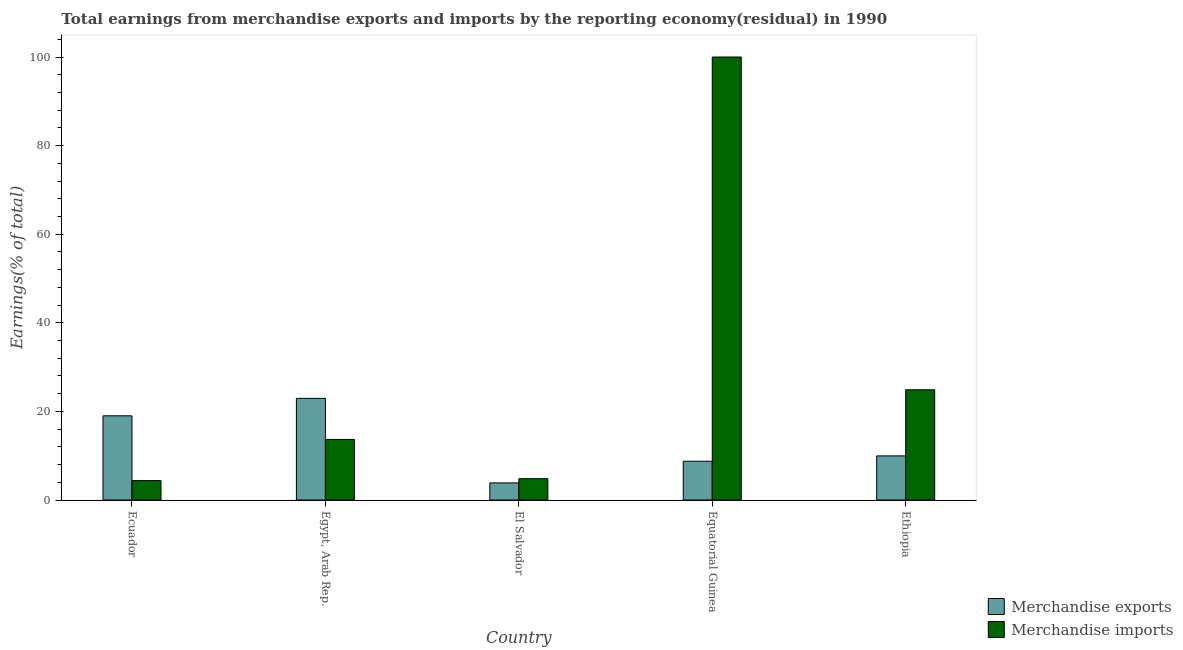How many different coloured bars are there?
Offer a terse response. 2. How many groups of bars are there?
Provide a short and direct response. 5. How many bars are there on the 5th tick from the left?
Keep it short and to the point. 2. What is the label of the 1st group of bars from the left?
Keep it short and to the point. Ecuador. What is the earnings from merchandise exports in El Salvador?
Keep it short and to the point. 3.86. Across all countries, what is the maximum earnings from merchandise exports?
Keep it short and to the point. 22.94. Across all countries, what is the minimum earnings from merchandise exports?
Make the answer very short. 3.86. In which country was the earnings from merchandise exports maximum?
Provide a short and direct response. Egypt, Arab Rep. In which country was the earnings from merchandise exports minimum?
Offer a terse response. El Salvador. What is the total earnings from merchandise exports in the graph?
Your response must be concise. 64.51. What is the difference between the earnings from merchandise exports in El Salvador and that in Equatorial Guinea?
Your answer should be very brief. -4.89. What is the difference between the earnings from merchandise imports in Ecuador and the earnings from merchandise exports in Equatorial Guinea?
Provide a short and direct response. -4.38. What is the average earnings from merchandise imports per country?
Your response must be concise. 29.55. What is the difference between the earnings from merchandise imports and earnings from merchandise exports in Ecuador?
Provide a succinct answer. -14.63. In how many countries, is the earnings from merchandise exports greater than 28 %?
Offer a terse response. 0. What is the ratio of the earnings from merchandise exports in Egypt, Arab Rep. to that in Equatorial Guinea?
Provide a succinct answer. 2.62. Is the difference between the earnings from merchandise exports in Ecuador and Equatorial Guinea greater than the difference between the earnings from merchandise imports in Ecuador and Equatorial Guinea?
Your response must be concise. Yes. What is the difference between the highest and the second highest earnings from merchandise exports?
Give a very brief answer. 3.94. What is the difference between the highest and the lowest earnings from merchandise exports?
Make the answer very short. 19.08. What does the 1st bar from the left in Egypt, Arab Rep. represents?
Give a very brief answer. Merchandise exports. How many bars are there?
Provide a succinct answer. 10. What is the difference between two consecutive major ticks on the Y-axis?
Provide a short and direct response. 20. Are the values on the major ticks of Y-axis written in scientific E-notation?
Make the answer very short. No. Does the graph contain any zero values?
Your response must be concise. No. Does the graph contain grids?
Make the answer very short. No. How many legend labels are there?
Make the answer very short. 2. How are the legend labels stacked?
Ensure brevity in your answer.  Vertical. What is the title of the graph?
Your response must be concise. Total earnings from merchandise exports and imports by the reporting economy(residual) in 1990. Does "IMF nonconcessional" appear as one of the legend labels in the graph?
Offer a terse response. No. What is the label or title of the Y-axis?
Give a very brief answer. Earnings(% of total). What is the Earnings(% of total) of Merchandise exports in Ecuador?
Your response must be concise. 19. What is the Earnings(% of total) in Merchandise imports in Ecuador?
Keep it short and to the point. 4.38. What is the Earnings(% of total) in Merchandise exports in Egypt, Arab Rep.?
Provide a short and direct response. 22.94. What is the Earnings(% of total) in Merchandise imports in Egypt, Arab Rep.?
Provide a succinct answer. 13.68. What is the Earnings(% of total) of Merchandise exports in El Salvador?
Provide a short and direct response. 3.86. What is the Earnings(% of total) in Merchandise imports in El Salvador?
Your answer should be compact. 4.81. What is the Earnings(% of total) of Merchandise exports in Equatorial Guinea?
Your answer should be very brief. 8.75. What is the Earnings(% of total) in Merchandise exports in Ethiopia?
Give a very brief answer. 9.96. What is the Earnings(% of total) in Merchandise imports in Ethiopia?
Your answer should be very brief. 24.88. Across all countries, what is the maximum Earnings(% of total) in Merchandise exports?
Ensure brevity in your answer.  22.94. Across all countries, what is the maximum Earnings(% of total) in Merchandise imports?
Your response must be concise. 100. Across all countries, what is the minimum Earnings(% of total) in Merchandise exports?
Your response must be concise. 3.86. Across all countries, what is the minimum Earnings(% of total) of Merchandise imports?
Offer a terse response. 4.38. What is the total Earnings(% of total) of Merchandise exports in the graph?
Keep it short and to the point. 64.51. What is the total Earnings(% of total) of Merchandise imports in the graph?
Provide a short and direct response. 147.75. What is the difference between the Earnings(% of total) in Merchandise exports in Ecuador and that in Egypt, Arab Rep.?
Give a very brief answer. -3.94. What is the difference between the Earnings(% of total) in Merchandise imports in Ecuador and that in Egypt, Arab Rep.?
Offer a very short reply. -9.3. What is the difference between the Earnings(% of total) of Merchandise exports in Ecuador and that in El Salvador?
Your response must be concise. 15.14. What is the difference between the Earnings(% of total) of Merchandise imports in Ecuador and that in El Salvador?
Your answer should be very brief. -0.43. What is the difference between the Earnings(% of total) of Merchandise exports in Ecuador and that in Equatorial Guinea?
Offer a terse response. 10.25. What is the difference between the Earnings(% of total) of Merchandise imports in Ecuador and that in Equatorial Guinea?
Provide a succinct answer. -95.62. What is the difference between the Earnings(% of total) in Merchandise exports in Ecuador and that in Ethiopia?
Ensure brevity in your answer.  9.05. What is the difference between the Earnings(% of total) in Merchandise imports in Ecuador and that in Ethiopia?
Ensure brevity in your answer.  -20.51. What is the difference between the Earnings(% of total) of Merchandise exports in Egypt, Arab Rep. and that in El Salvador?
Make the answer very short. 19.08. What is the difference between the Earnings(% of total) in Merchandise imports in Egypt, Arab Rep. and that in El Salvador?
Offer a terse response. 8.87. What is the difference between the Earnings(% of total) in Merchandise exports in Egypt, Arab Rep. and that in Equatorial Guinea?
Provide a short and direct response. 14.19. What is the difference between the Earnings(% of total) in Merchandise imports in Egypt, Arab Rep. and that in Equatorial Guinea?
Offer a very short reply. -86.32. What is the difference between the Earnings(% of total) of Merchandise exports in Egypt, Arab Rep. and that in Ethiopia?
Offer a terse response. 12.99. What is the difference between the Earnings(% of total) in Merchandise imports in Egypt, Arab Rep. and that in Ethiopia?
Keep it short and to the point. -11.21. What is the difference between the Earnings(% of total) of Merchandise exports in El Salvador and that in Equatorial Guinea?
Provide a short and direct response. -4.89. What is the difference between the Earnings(% of total) of Merchandise imports in El Salvador and that in Equatorial Guinea?
Give a very brief answer. -95.19. What is the difference between the Earnings(% of total) in Merchandise exports in El Salvador and that in Ethiopia?
Offer a terse response. -6.1. What is the difference between the Earnings(% of total) in Merchandise imports in El Salvador and that in Ethiopia?
Ensure brevity in your answer.  -20.07. What is the difference between the Earnings(% of total) in Merchandise exports in Equatorial Guinea and that in Ethiopia?
Keep it short and to the point. -1.2. What is the difference between the Earnings(% of total) in Merchandise imports in Equatorial Guinea and that in Ethiopia?
Keep it short and to the point. 75.12. What is the difference between the Earnings(% of total) in Merchandise exports in Ecuador and the Earnings(% of total) in Merchandise imports in Egypt, Arab Rep.?
Ensure brevity in your answer.  5.33. What is the difference between the Earnings(% of total) of Merchandise exports in Ecuador and the Earnings(% of total) of Merchandise imports in El Salvador?
Offer a very short reply. 14.19. What is the difference between the Earnings(% of total) in Merchandise exports in Ecuador and the Earnings(% of total) in Merchandise imports in Equatorial Guinea?
Keep it short and to the point. -81. What is the difference between the Earnings(% of total) of Merchandise exports in Ecuador and the Earnings(% of total) of Merchandise imports in Ethiopia?
Your response must be concise. -5.88. What is the difference between the Earnings(% of total) in Merchandise exports in Egypt, Arab Rep. and the Earnings(% of total) in Merchandise imports in El Salvador?
Offer a terse response. 18.13. What is the difference between the Earnings(% of total) of Merchandise exports in Egypt, Arab Rep. and the Earnings(% of total) of Merchandise imports in Equatorial Guinea?
Offer a very short reply. -77.06. What is the difference between the Earnings(% of total) of Merchandise exports in Egypt, Arab Rep. and the Earnings(% of total) of Merchandise imports in Ethiopia?
Your response must be concise. -1.94. What is the difference between the Earnings(% of total) of Merchandise exports in El Salvador and the Earnings(% of total) of Merchandise imports in Equatorial Guinea?
Keep it short and to the point. -96.14. What is the difference between the Earnings(% of total) of Merchandise exports in El Salvador and the Earnings(% of total) of Merchandise imports in Ethiopia?
Make the answer very short. -21.02. What is the difference between the Earnings(% of total) in Merchandise exports in Equatorial Guinea and the Earnings(% of total) in Merchandise imports in Ethiopia?
Ensure brevity in your answer.  -16.13. What is the average Earnings(% of total) in Merchandise exports per country?
Offer a very short reply. 12.9. What is the average Earnings(% of total) in Merchandise imports per country?
Provide a succinct answer. 29.55. What is the difference between the Earnings(% of total) in Merchandise exports and Earnings(% of total) in Merchandise imports in Ecuador?
Provide a succinct answer. 14.63. What is the difference between the Earnings(% of total) in Merchandise exports and Earnings(% of total) in Merchandise imports in Egypt, Arab Rep.?
Your answer should be very brief. 9.27. What is the difference between the Earnings(% of total) in Merchandise exports and Earnings(% of total) in Merchandise imports in El Salvador?
Make the answer very short. -0.95. What is the difference between the Earnings(% of total) in Merchandise exports and Earnings(% of total) in Merchandise imports in Equatorial Guinea?
Provide a succinct answer. -91.25. What is the difference between the Earnings(% of total) in Merchandise exports and Earnings(% of total) in Merchandise imports in Ethiopia?
Provide a short and direct response. -14.93. What is the ratio of the Earnings(% of total) in Merchandise exports in Ecuador to that in Egypt, Arab Rep.?
Make the answer very short. 0.83. What is the ratio of the Earnings(% of total) of Merchandise imports in Ecuador to that in Egypt, Arab Rep.?
Offer a very short reply. 0.32. What is the ratio of the Earnings(% of total) of Merchandise exports in Ecuador to that in El Salvador?
Keep it short and to the point. 4.92. What is the ratio of the Earnings(% of total) of Merchandise imports in Ecuador to that in El Salvador?
Ensure brevity in your answer.  0.91. What is the ratio of the Earnings(% of total) of Merchandise exports in Ecuador to that in Equatorial Guinea?
Your answer should be very brief. 2.17. What is the ratio of the Earnings(% of total) of Merchandise imports in Ecuador to that in Equatorial Guinea?
Your answer should be very brief. 0.04. What is the ratio of the Earnings(% of total) in Merchandise exports in Ecuador to that in Ethiopia?
Your answer should be very brief. 1.91. What is the ratio of the Earnings(% of total) of Merchandise imports in Ecuador to that in Ethiopia?
Offer a terse response. 0.18. What is the ratio of the Earnings(% of total) in Merchandise exports in Egypt, Arab Rep. to that in El Salvador?
Offer a terse response. 5.94. What is the ratio of the Earnings(% of total) of Merchandise imports in Egypt, Arab Rep. to that in El Salvador?
Ensure brevity in your answer.  2.84. What is the ratio of the Earnings(% of total) in Merchandise exports in Egypt, Arab Rep. to that in Equatorial Guinea?
Keep it short and to the point. 2.62. What is the ratio of the Earnings(% of total) of Merchandise imports in Egypt, Arab Rep. to that in Equatorial Guinea?
Ensure brevity in your answer.  0.14. What is the ratio of the Earnings(% of total) in Merchandise exports in Egypt, Arab Rep. to that in Ethiopia?
Provide a succinct answer. 2.3. What is the ratio of the Earnings(% of total) of Merchandise imports in Egypt, Arab Rep. to that in Ethiopia?
Provide a short and direct response. 0.55. What is the ratio of the Earnings(% of total) of Merchandise exports in El Salvador to that in Equatorial Guinea?
Make the answer very short. 0.44. What is the ratio of the Earnings(% of total) in Merchandise imports in El Salvador to that in Equatorial Guinea?
Make the answer very short. 0.05. What is the ratio of the Earnings(% of total) of Merchandise exports in El Salvador to that in Ethiopia?
Provide a short and direct response. 0.39. What is the ratio of the Earnings(% of total) of Merchandise imports in El Salvador to that in Ethiopia?
Offer a very short reply. 0.19. What is the ratio of the Earnings(% of total) of Merchandise exports in Equatorial Guinea to that in Ethiopia?
Give a very brief answer. 0.88. What is the ratio of the Earnings(% of total) in Merchandise imports in Equatorial Guinea to that in Ethiopia?
Ensure brevity in your answer.  4.02. What is the difference between the highest and the second highest Earnings(% of total) of Merchandise exports?
Make the answer very short. 3.94. What is the difference between the highest and the second highest Earnings(% of total) in Merchandise imports?
Give a very brief answer. 75.12. What is the difference between the highest and the lowest Earnings(% of total) in Merchandise exports?
Provide a succinct answer. 19.08. What is the difference between the highest and the lowest Earnings(% of total) in Merchandise imports?
Keep it short and to the point. 95.62. 